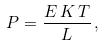<formula> <loc_0><loc_0><loc_500><loc_500>P = \frac { E \, K \, T } { L } \, ,</formula> 